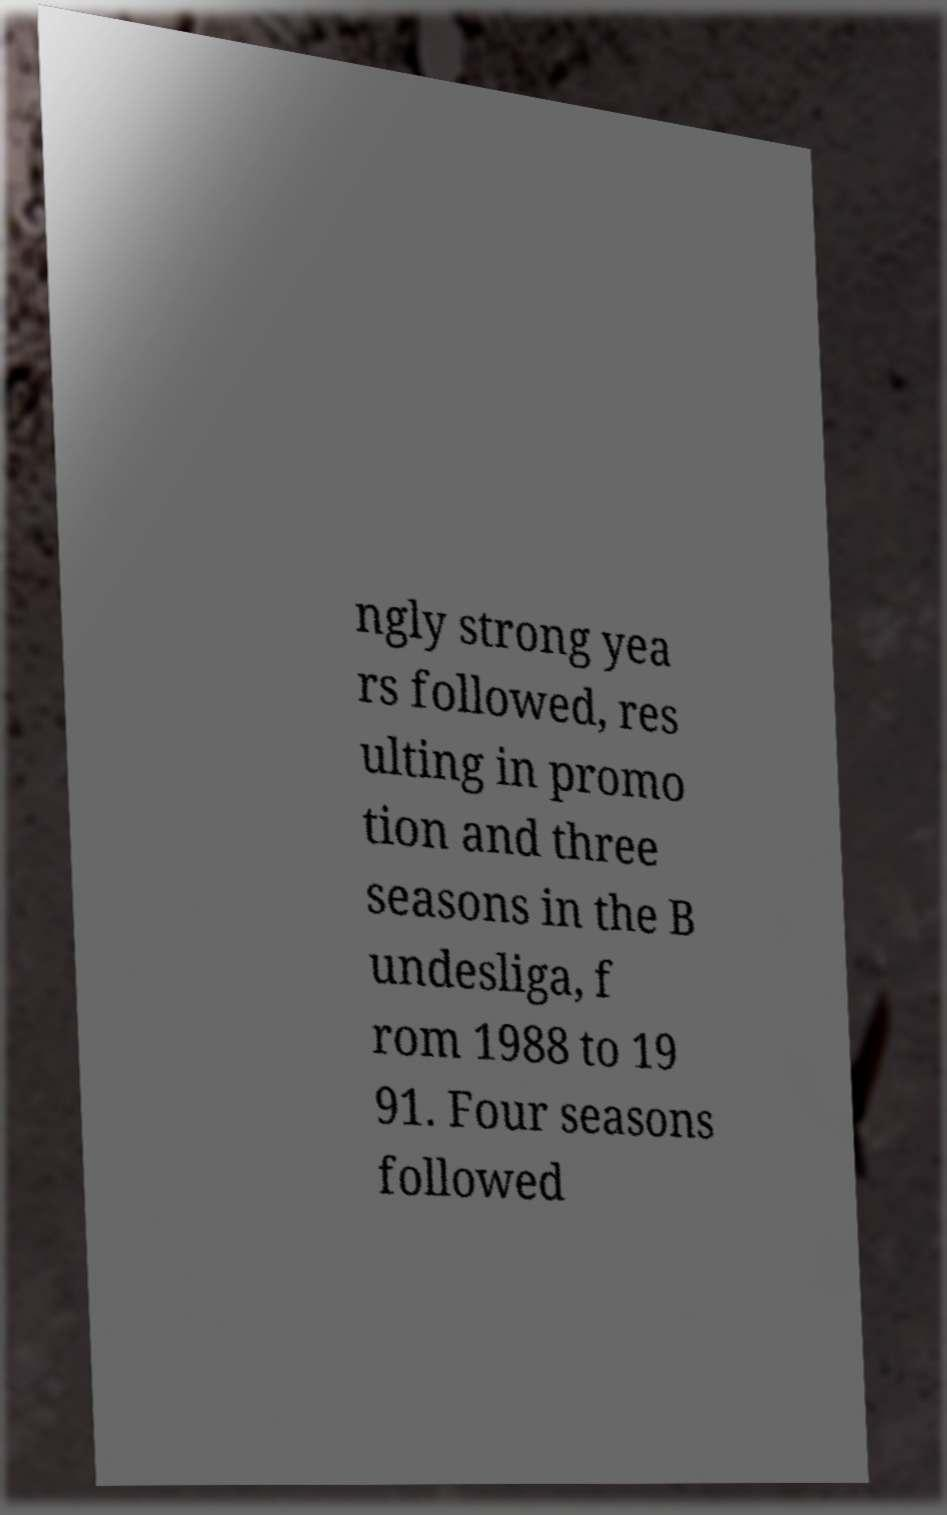There's text embedded in this image that I need extracted. Can you transcribe it verbatim? ngly strong yea rs followed, res ulting in promo tion and three seasons in the B undesliga, f rom 1988 to 19 91. Four seasons followed 